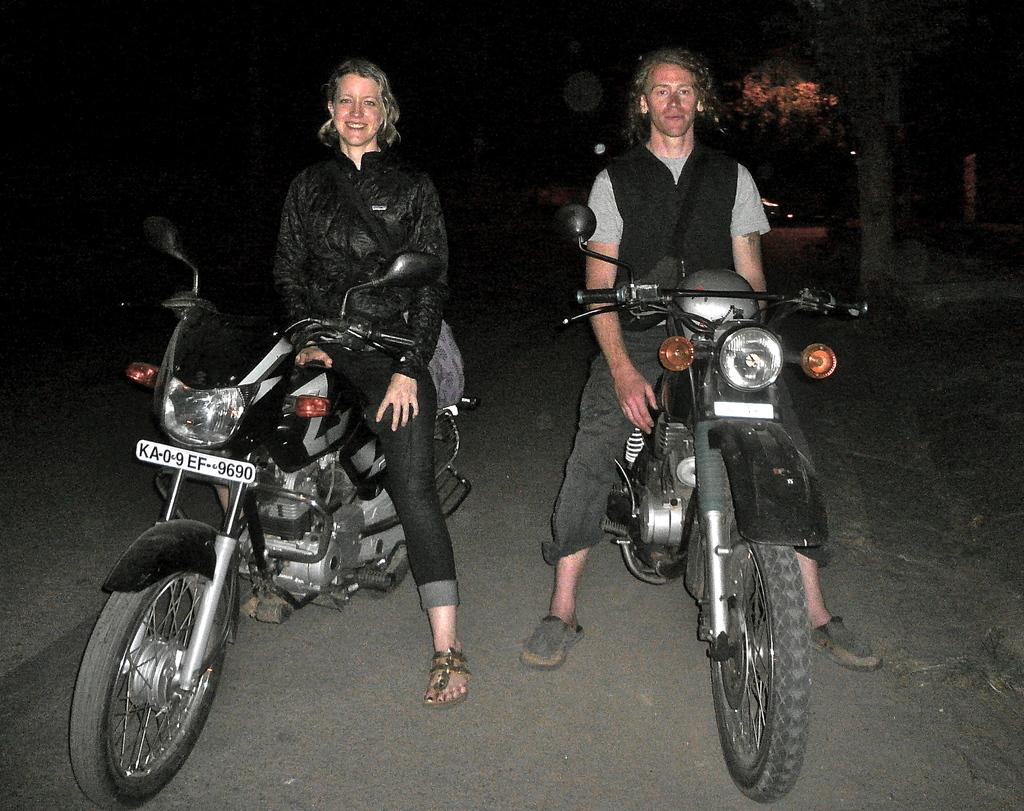How many people are in the image? There are two people in the image. Can you describe the individuals in the image? One of them is a woman and the other is a man. What are the people in the image doing? Both are sitting on bikes. How does the woman appear in the image? The woman is smiling. What can be seen in the background of the image? There are trees in the background of the image. What type of tooth is the man using to ride his bike in the image? There is no tooth present in the image, and the man is not using a tooth to ride his bike. What story is the woman telling the man while they are sitting on their bikes? There is no indication of a story being told in the image; the woman is simply smiling. 